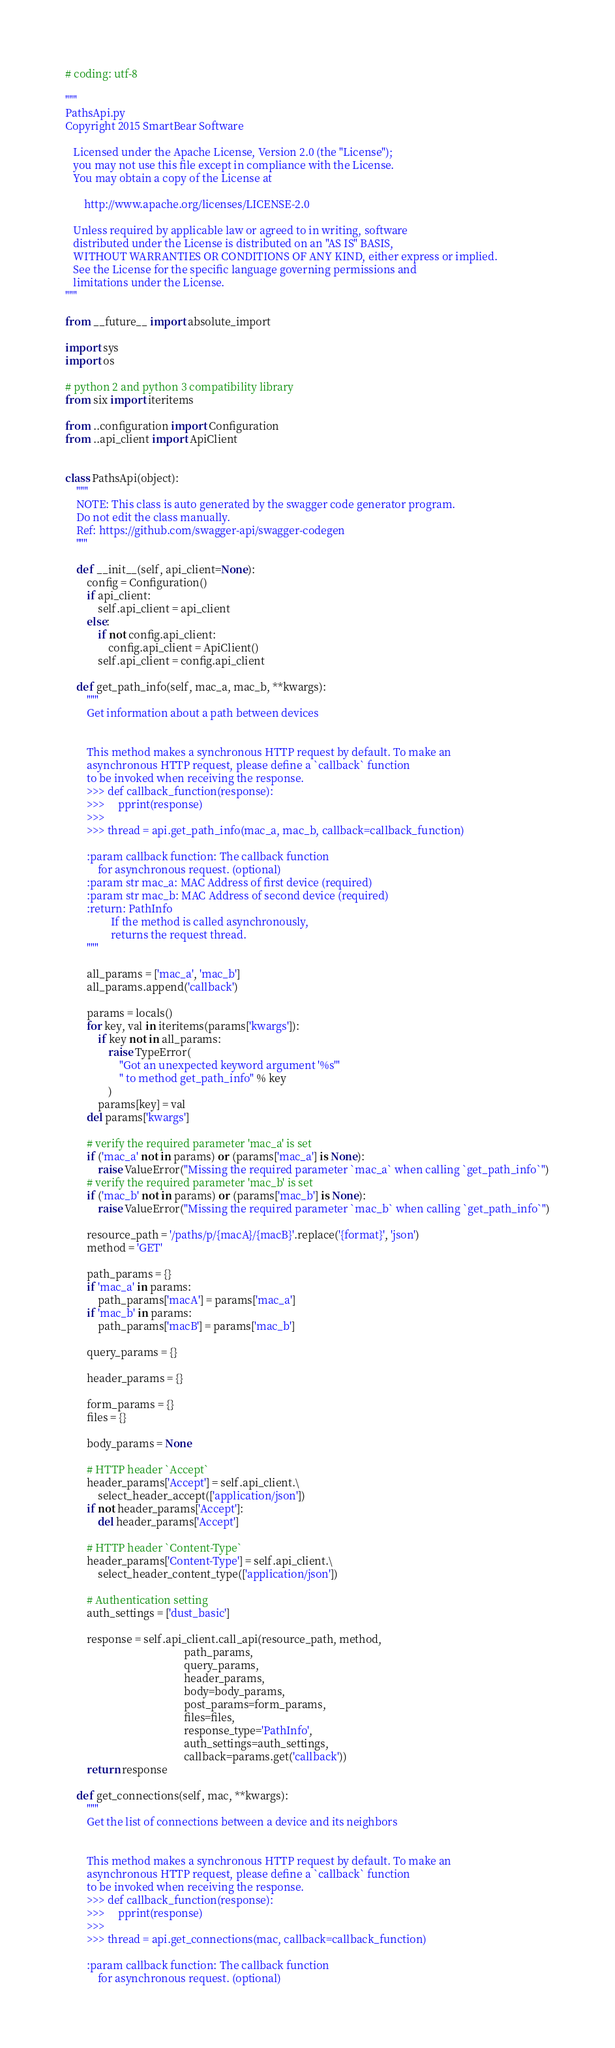<code> <loc_0><loc_0><loc_500><loc_500><_Python_># coding: utf-8

"""
PathsApi.py
Copyright 2015 SmartBear Software

   Licensed under the Apache License, Version 2.0 (the "License");
   you may not use this file except in compliance with the License.
   You may obtain a copy of the License at

       http://www.apache.org/licenses/LICENSE-2.0

   Unless required by applicable law or agreed to in writing, software
   distributed under the License is distributed on an "AS IS" BASIS,
   WITHOUT WARRANTIES OR CONDITIONS OF ANY KIND, either express or implied.
   See the License for the specific language governing permissions and
   limitations under the License.
"""

from __future__ import absolute_import

import sys
import os

# python 2 and python 3 compatibility library
from six import iteritems

from ..configuration import Configuration
from ..api_client import ApiClient


class PathsApi(object):
    """
    NOTE: This class is auto generated by the swagger code generator program.
    Do not edit the class manually.
    Ref: https://github.com/swagger-api/swagger-codegen
    """

    def __init__(self, api_client=None):
        config = Configuration()
        if api_client:
            self.api_client = api_client
        else:
            if not config.api_client:
                config.api_client = ApiClient()
            self.api_client = config.api_client

    def get_path_info(self, mac_a, mac_b, **kwargs):
        """
        Get information about a path between devices
        

        This method makes a synchronous HTTP request by default. To make an
        asynchronous HTTP request, please define a `callback` function
        to be invoked when receiving the response.
        >>> def callback_function(response):
        >>>     pprint(response)
        >>>
        >>> thread = api.get_path_info(mac_a, mac_b, callback=callback_function)

        :param callback function: The callback function
            for asynchronous request. (optional)
        :param str mac_a: MAC Address of first device (required)
        :param str mac_b: MAC Address of second device (required)
        :return: PathInfo
                 If the method is called asynchronously,
                 returns the request thread.
        """

        all_params = ['mac_a', 'mac_b']
        all_params.append('callback')

        params = locals()
        for key, val in iteritems(params['kwargs']):
            if key not in all_params:
                raise TypeError(
                    "Got an unexpected keyword argument '%s'"
                    " to method get_path_info" % key
                )
            params[key] = val
        del params['kwargs']

        # verify the required parameter 'mac_a' is set
        if ('mac_a' not in params) or (params['mac_a'] is None):
            raise ValueError("Missing the required parameter `mac_a` when calling `get_path_info`")
        # verify the required parameter 'mac_b' is set
        if ('mac_b' not in params) or (params['mac_b'] is None):
            raise ValueError("Missing the required parameter `mac_b` when calling `get_path_info`")

        resource_path = '/paths/p/{macA}/{macB}'.replace('{format}', 'json')
        method = 'GET'

        path_params = {}
        if 'mac_a' in params:
            path_params['macA'] = params['mac_a']
        if 'mac_b' in params:
            path_params['macB'] = params['mac_b']

        query_params = {}

        header_params = {}

        form_params = {}
        files = {}

        body_params = None

        # HTTP header `Accept`
        header_params['Accept'] = self.api_client.\
            select_header_accept(['application/json'])
        if not header_params['Accept']:
            del header_params['Accept']

        # HTTP header `Content-Type`
        header_params['Content-Type'] = self.api_client.\
            select_header_content_type(['application/json'])

        # Authentication setting
        auth_settings = ['dust_basic']

        response = self.api_client.call_api(resource_path, method,
                                            path_params,
                                            query_params,
                                            header_params,
                                            body=body_params,
                                            post_params=form_params,
                                            files=files,
                                            response_type='PathInfo',
                                            auth_settings=auth_settings,
                                            callback=params.get('callback'))
        return response

    def get_connections(self, mac, **kwargs):
        """
        Get the list of connections between a device and its neighbors
        

        This method makes a synchronous HTTP request by default. To make an
        asynchronous HTTP request, please define a `callback` function
        to be invoked when receiving the response.
        >>> def callback_function(response):
        >>>     pprint(response)
        >>>
        >>> thread = api.get_connections(mac, callback=callback_function)

        :param callback function: The callback function
            for asynchronous request. (optional)</code> 